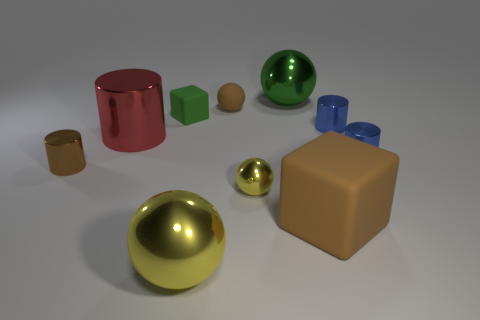There is a large ball that is made of the same material as the large yellow object; what color is it?
Provide a succinct answer. Green. Does the small block have the same material as the small brown object right of the large yellow object?
Keep it short and to the point. Yes. What color is the big thing that is both on the right side of the red cylinder and on the left side of the tiny rubber sphere?
Your response must be concise. Yellow. How many blocks are red shiny things or large objects?
Offer a very short reply. 1. Does the large brown rubber thing have the same shape as the matte object that is to the left of the big yellow object?
Ensure brevity in your answer.  Yes. There is a object that is both behind the small green rubber thing and to the right of the brown matte sphere; how big is it?
Offer a terse response. Large. What is the shape of the small brown metal object?
Provide a succinct answer. Cylinder. There is a small brown object that is to the right of the brown shiny cylinder; is there a brown matte cube to the left of it?
Your answer should be compact. No. There is a big sphere behind the large rubber cube; how many brown cylinders are behind it?
Offer a very short reply. 0. What material is the brown sphere that is the same size as the green rubber block?
Ensure brevity in your answer.  Rubber. 